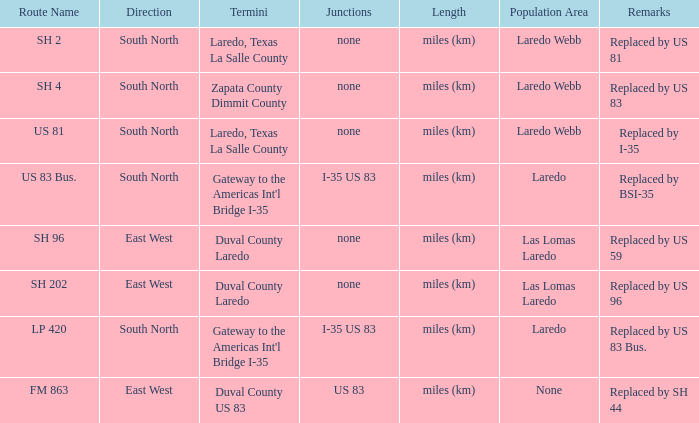How many termini are there that have "east west" listed in their direction section, "none" listed in their junction section, and have a route name of "sh 202"? 1.0. 